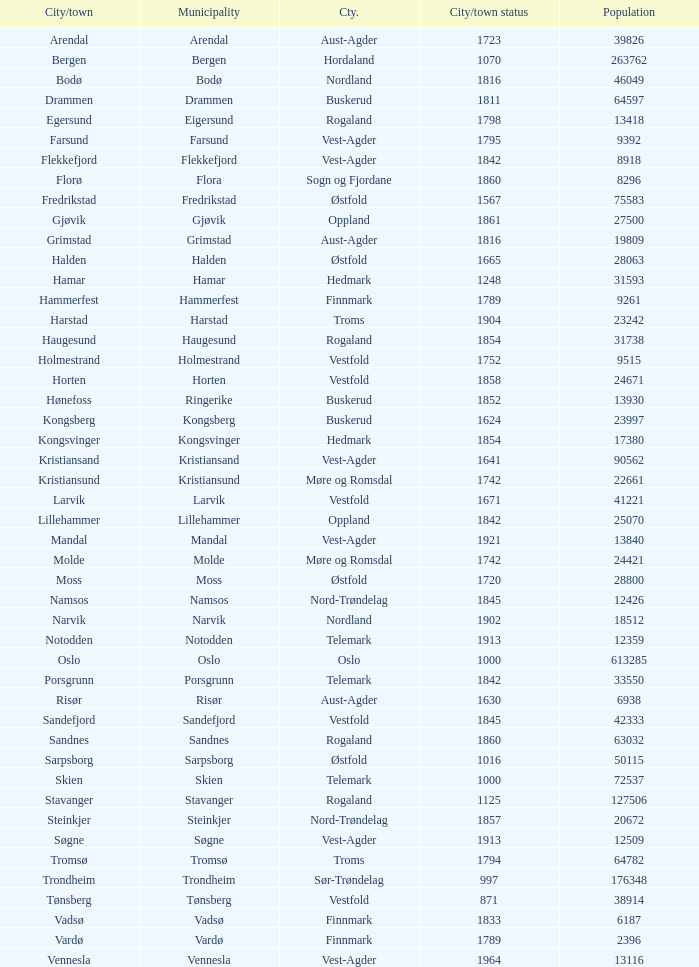I'm looking to parse the entire table for insights. Could you assist me with that? {'header': ['City/town', 'Municipality', 'Cty.', 'City/town status', 'Population'], 'rows': [['Arendal', 'Arendal', 'Aust-Agder', '1723', '39826'], ['Bergen', 'Bergen', 'Hordaland', '1070', '263762'], ['Bodø', 'Bodø', 'Nordland', '1816', '46049'], ['Drammen', 'Drammen', 'Buskerud', '1811', '64597'], ['Egersund', 'Eigersund', 'Rogaland', '1798', '13418'], ['Farsund', 'Farsund', 'Vest-Agder', '1795', '9392'], ['Flekkefjord', 'Flekkefjord', 'Vest-Agder', '1842', '8918'], ['Florø', 'Flora', 'Sogn og Fjordane', '1860', '8296'], ['Fredrikstad', 'Fredrikstad', 'Østfold', '1567', '75583'], ['Gjøvik', 'Gjøvik', 'Oppland', '1861', '27500'], ['Grimstad', 'Grimstad', 'Aust-Agder', '1816', '19809'], ['Halden', 'Halden', 'Østfold', '1665', '28063'], ['Hamar', 'Hamar', 'Hedmark', '1248', '31593'], ['Hammerfest', 'Hammerfest', 'Finnmark', '1789', '9261'], ['Harstad', 'Harstad', 'Troms', '1904', '23242'], ['Haugesund', 'Haugesund', 'Rogaland', '1854', '31738'], ['Holmestrand', 'Holmestrand', 'Vestfold', '1752', '9515'], ['Horten', 'Horten', 'Vestfold', '1858', '24671'], ['Hønefoss', 'Ringerike', 'Buskerud', '1852', '13930'], ['Kongsberg', 'Kongsberg', 'Buskerud', '1624', '23997'], ['Kongsvinger', 'Kongsvinger', 'Hedmark', '1854', '17380'], ['Kristiansand', 'Kristiansand', 'Vest-Agder', '1641', '90562'], ['Kristiansund', 'Kristiansund', 'Møre og Romsdal', '1742', '22661'], ['Larvik', 'Larvik', 'Vestfold', '1671', '41221'], ['Lillehammer', 'Lillehammer', 'Oppland', '1842', '25070'], ['Mandal', 'Mandal', 'Vest-Agder', '1921', '13840'], ['Molde', 'Molde', 'Møre og Romsdal', '1742', '24421'], ['Moss', 'Moss', 'Østfold', '1720', '28800'], ['Namsos', 'Namsos', 'Nord-Trøndelag', '1845', '12426'], ['Narvik', 'Narvik', 'Nordland', '1902', '18512'], ['Notodden', 'Notodden', 'Telemark', '1913', '12359'], ['Oslo', 'Oslo', 'Oslo', '1000', '613285'], ['Porsgrunn', 'Porsgrunn', 'Telemark', '1842', '33550'], ['Risør', 'Risør', 'Aust-Agder', '1630', '6938'], ['Sandefjord', 'Sandefjord', 'Vestfold', '1845', '42333'], ['Sandnes', 'Sandnes', 'Rogaland', '1860', '63032'], ['Sarpsborg', 'Sarpsborg', 'Østfold', '1016', '50115'], ['Skien', 'Skien', 'Telemark', '1000', '72537'], ['Stavanger', 'Stavanger', 'Rogaland', '1125', '127506'], ['Steinkjer', 'Steinkjer', 'Nord-Trøndelag', '1857', '20672'], ['Søgne', 'Søgne', 'Vest-Agder', '1913', '12509'], ['Tromsø', 'Tromsø', 'Troms', '1794', '64782'], ['Trondheim', 'Trondheim', 'Sør-Trøndelag', '997', '176348'], ['Tønsberg', 'Tønsberg', 'Vestfold', '871', '38914'], ['Vadsø', 'Vadsø', 'Finnmark', '1833', '6187'], ['Vardø', 'Vardø', 'Finnmark', '1789', '2396'], ['Vennesla', 'Vennesla', 'Vest-Agder', '1964', '13116']]} In finnmark county, can you identify the municipalities with populations larger than 6187.0? Hammerfest. 